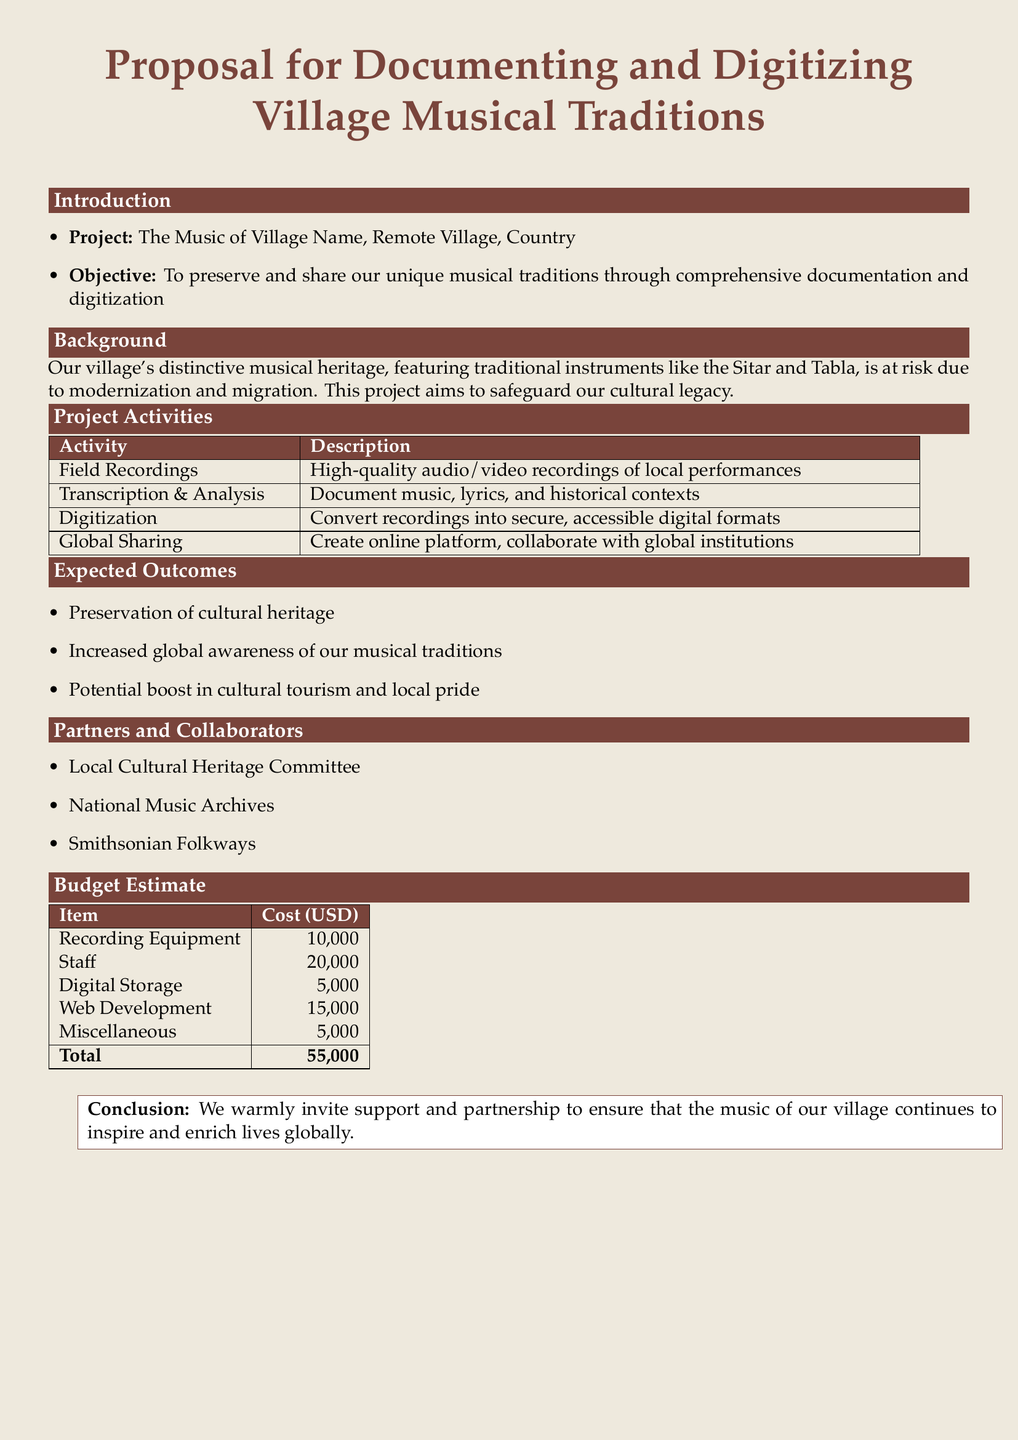What is the project title? The project title is explicitly mentioned in the introduction section of the document, which is "The Music of Village Name, Remote Village, Country".
Answer: The Music of Village Name, Remote Village, Country What is the total budget estimate? The total budget estimate is clearly provided in the budget table at the end of the document.
Answer: 55,000 What is one traditional instrument mentioned in the document? The document refers to traditional instruments in the background section, listing "Sitar" as an example.
Answer: Sitar Which organization is mentioned as a partner? The partners and collaborators section lists several organizations, one of which is "Smithsonian Folkways".
Answer: Smithsonian Folkways What type of activity involves "high-quality audio/video recordings"? The project activities table specifies that “Field Recordings” involves this type of activity.
Answer: Field Recordings What is the objective of the project? The objective is stated in the introduction section: it is to preserve and share unique musical traditions.
Answer: To preserve and share our unique musical traditions What is the expected outcome regarding cultural tourism? One of the expected outcomes mentioned in the outcomes section relates to "Potential boost in cultural tourism".
Answer: Potential boost in cultural tourism How much is allocated for staff costs? The budget estimate table specifies the cost allocation for staff clearly as "20,000".
Answer: 20,000 What is the purpose of the proposed online platform? The global sharing activity describes the purpose, which is to create an online platform.
Answer: Create online platform 